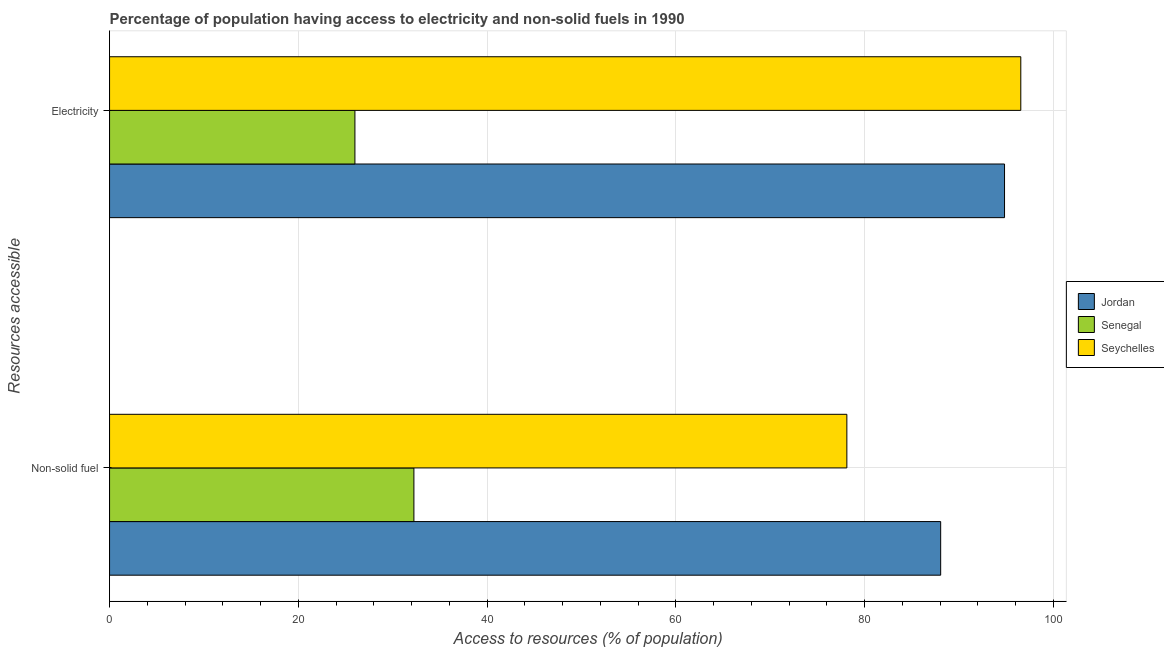How many different coloured bars are there?
Offer a very short reply. 3. How many groups of bars are there?
Provide a succinct answer. 2. Are the number of bars on each tick of the Y-axis equal?
Give a very brief answer. Yes. What is the label of the 1st group of bars from the top?
Make the answer very short. Electricity. What is the percentage of population having access to non-solid fuel in Jordan?
Offer a terse response. 88.07. Across all countries, what is the maximum percentage of population having access to electricity?
Offer a very short reply. 96.56. Across all countries, what is the minimum percentage of population having access to non-solid fuel?
Ensure brevity in your answer.  32.25. In which country was the percentage of population having access to non-solid fuel maximum?
Give a very brief answer. Jordan. In which country was the percentage of population having access to electricity minimum?
Provide a succinct answer. Senegal. What is the total percentage of population having access to electricity in the graph?
Offer a very short reply. 217.4. What is the difference between the percentage of population having access to electricity in Senegal and that in Seychelles?
Ensure brevity in your answer.  -70.56. What is the difference between the percentage of population having access to electricity in Jordan and the percentage of population having access to non-solid fuel in Senegal?
Give a very brief answer. 62.59. What is the average percentage of population having access to electricity per country?
Make the answer very short. 72.47. What is the difference between the percentage of population having access to non-solid fuel and percentage of population having access to electricity in Senegal?
Offer a very short reply. 6.25. What is the ratio of the percentage of population having access to non-solid fuel in Seychelles to that in Jordan?
Offer a very short reply. 0.89. Is the percentage of population having access to non-solid fuel in Jordan less than that in Seychelles?
Ensure brevity in your answer.  No. In how many countries, is the percentage of population having access to non-solid fuel greater than the average percentage of population having access to non-solid fuel taken over all countries?
Keep it short and to the point. 2. What does the 1st bar from the top in Electricity represents?
Your answer should be compact. Seychelles. What does the 3rd bar from the bottom in Non-solid fuel represents?
Your response must be concise. Seychelles. Are all the bars in the graph horizontal?
Your response must be concise. Yes. How many countries are there in the graph?
Your response must be concise. 3. What is the difference between two consecutive major ticks on the X-axis?
Provide a short and direct response. 20. Are the values on the major ticks of X-axis written in scientific E-notation?
Give a very brief answer. No. Does the graph contain any zero values?
Ensure brevity in your answer.  No. How many legend labels are there?
Keep it short and to the point. 3. How are the legend labels stacked?
Ensure brevity in your answer.  Vertical. What is the title of the graph?
Ensure brevity in your answer.  Percentage of population having access to electricity and non-solid fuels in 1990. What is the label or title of the X-axis?
Make the answer very short. Access to resources (% of population). What is the label or title of the Y-axis?
Your answer should be very brief. Resources accessible. What is the Access to resources (% of population) of Jordan in Non-solid fuel?
Your response must be concise. 88.07. What is the Access to resources (% of population) of Senegal in Non-solid fuel?
Offer a terse response. 32.25. What is the Access to resources (% of population) of Seychelles in Non-solid fuel?
Provide a succinct answer. 78.13. What is the Access to resources (% of population) in Jordan in Electricity?
Keep it short and to the point. 94.84. What is the Access to resources (% of population) of Senegal in Electricity?
Keep it short and to the point. 26. What is the Access to resources (% of population) in Seychelles in Electricity?
Offer a terse response. 96.56. Across all Resources accessible, what is the maximum Access to resources (% of population) of Jordan?
Your response must be concise. 94.84. Across all Resources accessible, what is the maximum Access to resources (% of population) in Senegal?
Your answer should be very brief. 32.25. Across all Resources accessible, what is the maximum Access to resources (% of population) of Seychelles?
Your response must be concise. 96.56. Across all Resources accessible, what is the minimum Access to resources (% of population) of Jordan?
Provide a succinct answer. 88.07. Across all Resources accessible, what is the minimum Access to resources (% of population) of Senegal?
Offer a terse response. 26. Across all Resources accessible, what is the minimum Access to resources (% of population) in Seychelles?
Provide a short and direct response. 78.13. What is the total Access to resources (% of population) in Jordan in the graph?
Your answer should be compact. 182.91. What is the total Access to resources (% of population) in Senegal in the graph?
Ensure brevity in your answer.  58.25. What is the total Access to resources (% of population) of Seychelles in the graph?
Offer a terse response. 174.69. What is the difference between the Access to resources (% of population) in Jordan in Non-solid fuel and that in Electricity?
Offer a terse response. -6.77. What is the difference between the Access to resources (% of population) of Senegal in Non-solid fuel and that in Electricity?
Your response must be concise. 6.25. What is the difference between the Access to resources (% of population) in Seychelles in Non-solid fuel and that in Electricity?
Offer a terse response. -18.43. What is the difference between the Access to resources (% of population) of Jordan in Non-solid fuel and the Access to resources (% of population) of Senegal in Electricity?
Offer a very short reply. 62.07. What is the difference between the Access to resources (% of population) of Jordan in Non-solid fuel and the Access to resources (% of population) of Seychelles in Electricity?
Provide a succinct answer. -8.49. What is the difference between the Access to resources (% of population) of Senegal in Non-solid fuel and the Access to resources (% of population) of Seychelles in Electricity?
Offer a very short reply. -64.31. What is the average Access to resources (% of population) in Jordan per Resources accessible?
Provide a short and direct response. 91.45. What is the average Access to resources (% of population) of Senegal per Resources accessible?
Keep it short and to the point. 29.13. What is the average Access to resources (% of population) of Seychelles per Resources accessible?
Provide a short and direct response. 87.34. What is the difference between the Access to resources (% of population) of Jordan and Access to resources (% of population) of Senegal in Non-solid fuel?
Your answer should be compact. 55.82. What is the difference between the Access to resources (% of population) in Jordan and Access to resources (% of population) in Seychelles in Non-solid fuel?
Your response must be concise. 9.94. What is the difference between the Access to resources (% of population) in Senegal and Access to resources (% of population) in Seychelles in Non-solid fuel?
Offer a terse response. -45.88. What is the difference between the Access to resources (% of population) in Jordan and Access to resources (% of population) in Senegal in Electricity?
Give a very brief answer. 68.84. What is the difference between the Access to resources (% of population) in Jordan and Access to resources (% of population) in Seychelles in Electricity?
Your response must be concise. -1.72. What is the difference between the Access to resources (% of population) in Senegal and Access to resources (% of population) in Seychelles in Electricity?
Give a very brief answer. -70.56. What is the ratio of the Access to resources (% of population) in Jordan in Non-solid fuel to that in Electricity?
Make the answer very short. 0.93. What is the ratio of the Access to resources (% of population) in Senegal in Non-solid fuel to that in Electricity?
Provide a short and direct response. 1.24. What is the ratio of the Access to resources (% of population) in Seychelles in Non-solid fuel to that in Electricity?
Your answer should be compact. 0.81. What is the difference between the highest and the second highest Access to resources (% of population) in Jordan?
Ensure brevity in your answer.  6.77. What is the difference between the highest and the second highest Access to resources (% of population) of Senegal?
Give a very brief answer. 6.25. What is the difference between the highest and the second highest Access to resources (% of population) in Seychelles?
Offer a terse response. 18.43. What is the difference between the highest and the lowest Access to resources (% of population) in Jordan?
Your answer should be compact. 6.77. What is the difference between the highest and the lowest Access to resources (% of population) in Senegal?
Your response must be concise. 6.25. What is the difference between the highest and the lowest Access to resources (% of population) of Seychelles?
Ensure brevity in your answer.  18.43. 